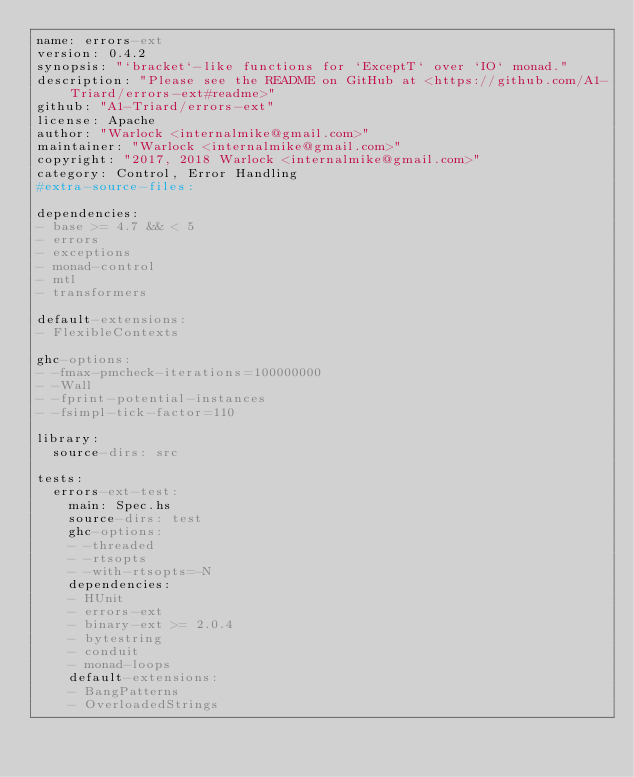<code> <loc_0><loc_0><loc_500><loc_500><_YAML_>name: errors-ext
version: 0.4.2
synopsis: "`bracket`-like functions for `ExceptT` over `IO` monad."
description: "Please see the README on GitHub at <https://github.com/A1-Triard/errors-ext#readme>"
github: "A1-Triard/errors-ext"
license: Apache
author: "Warlock <internalmike@gmail.com>"
maintainer: "Warlock <internalmike@gmail.com>"
copyright: "2017, 2018 Warlock <internalmike@gmail.com>"
category: Control, Error Handling
#extra-source-files:

dependencies:
- base >= 4.7 && < 5
- errors
- exceptions
- monad-control
- mtl
- transformers

default-extensions:
- FlexibleContexts

ghc-options:
- -fmax-pmcheck-iterations=100000000
- -Wall
- -fprint-potential-instances
- -fsimpl-tick-factor=110

library:
  source-dirs: src

tests:
  errors-ext-test:
    main: Spec.hs
    source-dirs: test
    ghc-options:
    - -threaded
    - -rtsopts
    - -with-rtsopts=-N
    dependencies:
    - HUnit
    - errors-ext
    - binary-ext >= 2.0.4
    - bytestring
    - conduit
    - monad-loops
    default-extensions:
    - BangPatterns
    - OverloadedStrings
</code> 